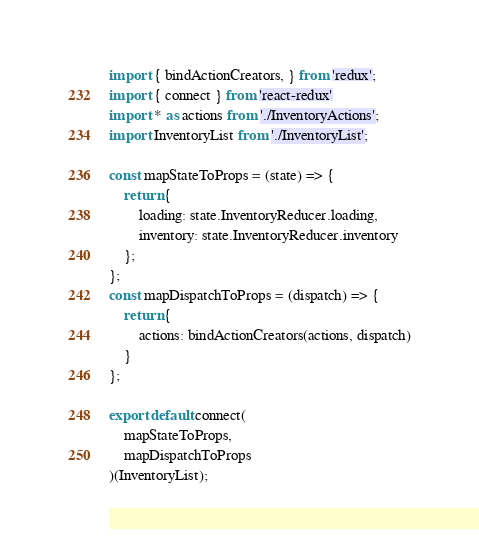<code> <loc_0><loc_0><loc_500><loc_500><_JavaScript_>import { bindActionCreators, } from 'redux';
import { connect } from 'react-redux'
import * as actions from './InventoryActions';
import InventoryList from './InventoryList';

const mapStateToProps = (state) => {
    return {
        loading: state.InventoryReducer.loading,
        inventory: state.InventoryReducer.inventory
    };
};
const mapDispatchToProps = (dispatch) => {
    return {
        actions: bindActionCreators(actions, dispatch)
    }
};

export default connect(
    mapStateToProps,
    mapDispatchToProps
)(InventoryList);</code> 